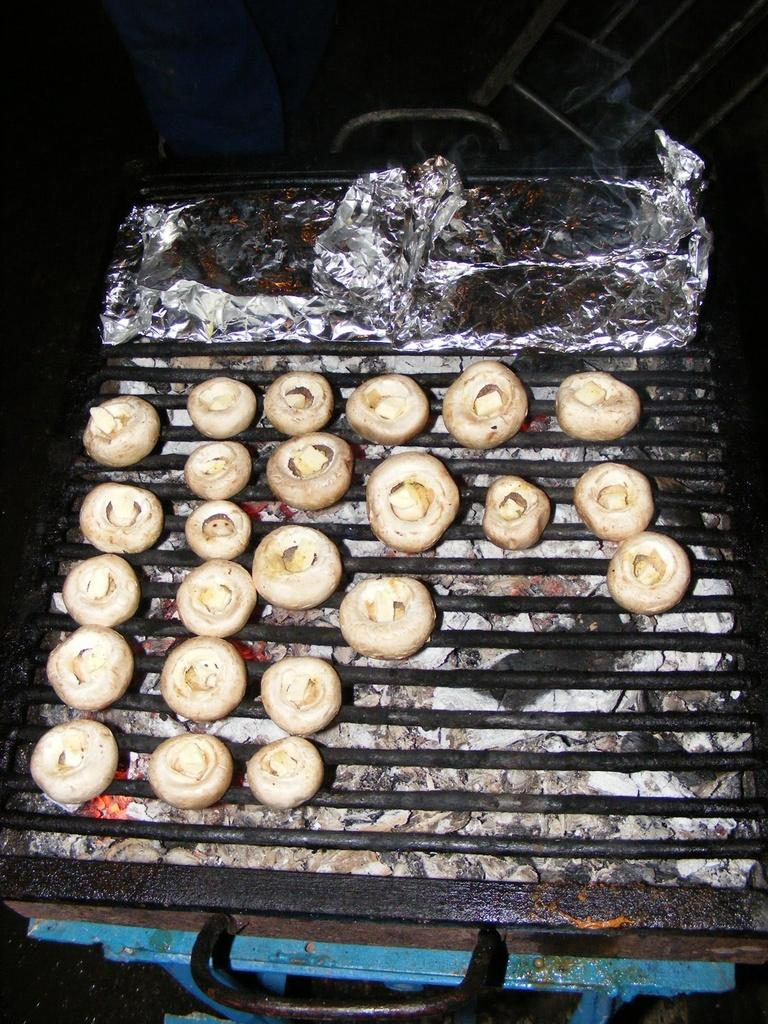What is being cooked on the grill in the image? There are food items on the grill in the image. What colors are the food items on the grill? The food items are in white and cream color. What material is visible in the image? There is a silver foil visible in the image. Where is the gun located in the image? There is no gun present in the image. What type of house is shown in the image? There is no house shown in the image; it features food items on a grill. 